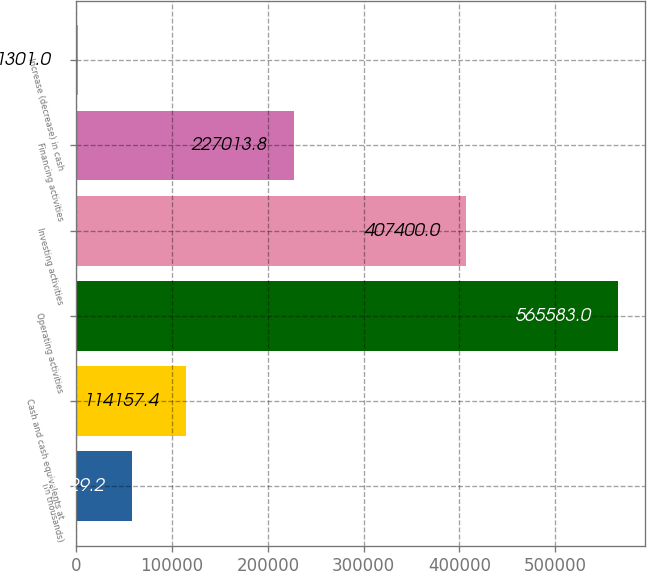Convert chart. <chart><loc_0><loc_0><loc_500><loc_500><bar_chart><fcel>(In thousands)<fcel>Cash and cash equivalents at<fcel>Operating activities<fcel>Investing activities<fcel>Financing activities<fcel>Increase (decrease) in cash<nl><fcel>57729.2<fcel>114157<fcel>565583<fcel>407400<fcel>227014<fcel>1301<nl></chart> 